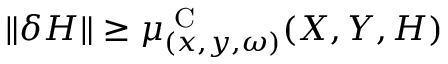Convert formula to latex. <formula><loc_0><loc_0><loc_500><loc_500>\| \delta H \| \geq \mu _ { ( x , y , \omega ) } ^ { C } ( X , Y , H )</formula> 